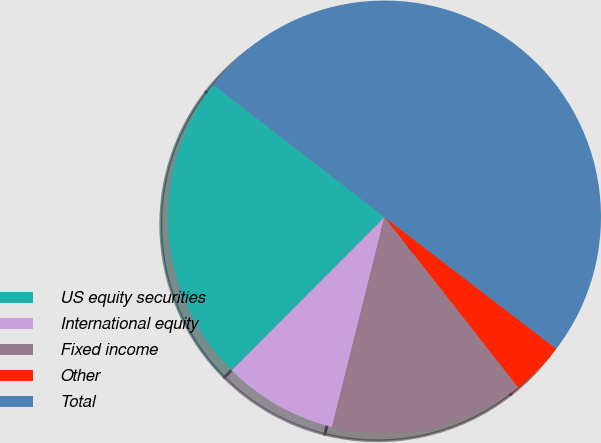Convert chart. <chart><loc_0><loc_0><loc_500><loc_500><pie_chart><fcel>US equity securities<fcel>International equity<fcel>Fixed income<fcel>Other<fcel>Total<nl><fcel>22.98%<fcel>8.59%<fcel>14.49%<fcel>4.0%<fcel>49.95%<nl></chart> 